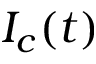Convert formula to latex. <formula><loc_0><loc_0><loc_500><loc_500>I _ { c } ( t )</formula> 